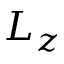<formula> <loc_0><loc_0><loc_500><loc_500>L _ { z }</formula> 